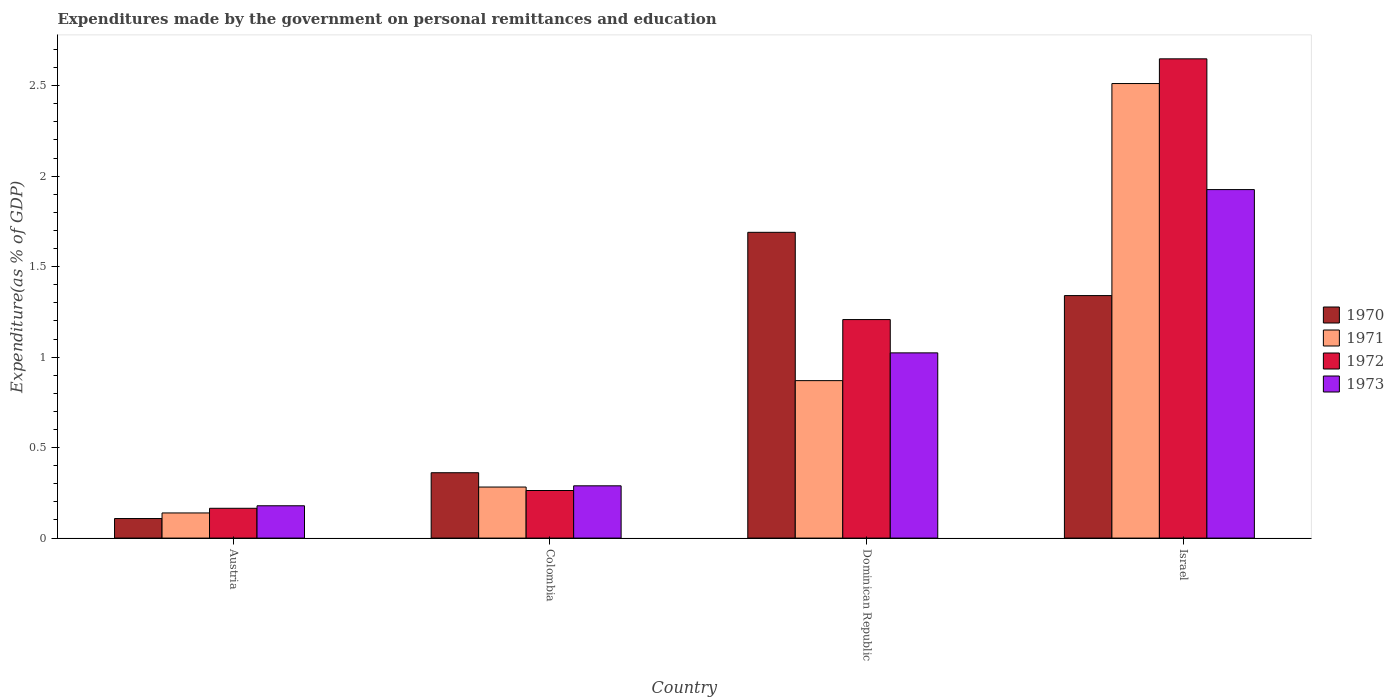How many different coloured bars are there?
Keep it short and to the point. 4. How many bars are there on the 4th tick from the left?
Make the answer very short. 4. How many bars are there on the 1st tick from the right?
Provide a short and direct response. 4. What is the label of the 3rd group of bars from the left?
Provide a succinct answer. Dominican Republic. What is the expenditures made by the government on personal remittances and education in 1973 in Austria?
Your response must be concise. 0.18. Across all countries, what is the maximum expenditures made by the government on personal remittances and education in 1973?
Your answer should be compact. 1.93. Across all countries, what is the minimum expenditures made by the government on personal remittances and education in 1972?
Provide a short and direct response. 0.16. In which country was the expenditures made by the government on personal remittances and education in 1971 minimum?
Provide a succinct answer. Austria. What is the total expenditures made by the government on personal remittances and education in 1970 in the graph?
Your answer should be very brief. 3.5. What is the difference between the expenditures made by the government on personal remittances and education in 1973 in Dominican Republic and that in Israel?
Your answer should be very brief. -0.9. What is the difference between the expenditures made by the government on personal remittances and education in 1971 in Colombia and the expenditures made by the government on personal remittances and education in 1972 in Dominican Republic?
Ensure brevity in your answer.  -0.93. What is the average expenditures made by the government on personal remittances and education in 1971 per country?
Make the answer very short. 0.95. What is the difference between the expenditures made by the government on personal remittances and education of/in 1972 and expenditures made by the government on personal remittances and education of/in 1971 in Colombia?
Keep it short and to the point. -0.02. What is the ratio of the expenditures made by the government on personal remittances and education in 1971 in Colombia to that in Dominican Republic?
Ensure brevity in your answer.  0.32. Is the expenditures made by the government on personal remittances and education in 1970 in Austria less than that in Dominican Republic?
Your answer should be compact. Yes. Is the difference between the expenditures made by the government on personal remittances and education in 1972 in Colombia and Dominican Republic greater than the difference between the expenditures made by the government on personal remittances and education in 1971 in Colombia and Dominican Republic?
Provide a short and direct response. No. What is the difference between the highest and the second highest expenditures made by the government on personal remittances and education in 1970?
Offer a terse response. -1.33. What is the difference between the highest and the lowest expenditures made by the government on personal remittances and education in 1971?
Ensure brevity in your answer.  2.37. Is it the case that in every country, the sum of the expenditures made by the government on personal remittances and education in 1971 and expenditures made by the government on personal remittances and education in 1973 is greater than the sum of expenditures made by the government on personal remittances and education in 1972 and expenditures made by the government on personal remittances and education in 1970?
Your answer should be compact. No. What does the 2nd bar from the left in Israel represents?
Keep it short and to the point. 1971. What does the 3rd bar from the right in Colombia represents?
Offer a very short reply. 1971. Is it the case that in every country, the sum of the expenditures made by the government on personal remittances and education in 1972 and expenditures made by the government on personal remittances and education in 1971 is greater than the expenditures made by the government on personal remittances and education in 1970?
Ensure brevity in your answer.  Yes. What is the difference between two consecutive major ticks on the Y-axis?
Your answer should be very brief. 0.5. Does the graph contain any zero values?
Give a very brief answer. No. Does the graph contain grids?
Provide a short and direct response. No. Where does the legend appear in the graph?
Provide a succinct answer. Center right. How are the legend labels stacked?
Your response must be concise. Vertical. What is the title of the graph?
Provide a short and direct response. Expenditures made by the government on personal remittances and education. What is the label or title of the X-axis?
Ensure brevity in your answer.  Country. What is the label or title of the Y-axis?
Give a very brief answer. Expenditure(as % of GDP). What is the Expenditure(as % of GDP) of 1970 in Austria?
Your response must be concise. 0.11. What is the Expenditure(as % of GDP) in 1971 in Austria?
Make the answer very short. 0.14. What is the Expenditure(as % of GDP) in 1972 in Austria?
Provide a short and direct response. 0.16. What is the Expenditure(as % of GDP) of 1973 in Austria?
Provide a short and direct response. 0.18. What is the Expenditure(as % of GDP) in 1970 in Colombia?
Offer a very short reply. 0.36. What is the Expenditure(as % of GDP) of 1971 in Colombia?
Give a very brief answer. 0.28. What is the Expenditure(as % of GDP) of 1972 in Colombia?
Your answer should be compact. 0.26. What is the Expenditure(as % of GDP) of 1973 in Colombia?
Your answer should be compact. 0.29. What is the Expenditure(as % of GDP) of 1970 in Dominican Republic?
Offer a terse response. 1.69. What is the Expenditure(as % of GDP) in 1971 in Dominican Republic?
Your response must be concise. 0.87. What is the Expenditure(as % of GDP) in 1972 in Dominican Republic?
Provide a succinct answer. 1.21. What is the Expenditure(as % of GDP) in 1973 in Dominican Republic?
Ensure brevity in your answer.  1.02. What is the Expenditure(as % of GDP) in 1970 in Israel?
Offer a very short reply. 1.34. What is the Expenditure(as % of GDP) of 1971 in Israel?
Give a very brief answer. 2.51. What is the Expenditure(as % of GDP) in 1972 in Israel?
Offer a very short reply. 2.65. What is the Expenditure(as % of GDP) of 1973 in Israel?
Your answer should be very brief. 1.93. Across all countries, what is the maximum Expenditure(as % of GDP) in 1970?
Provide a short and direct response. 1.69. Across all countries, what is the maximum Expenditure(as % of GDP) of 1971?
Keep it short and to the point. 2.51. Across all countries, what is the maximum Expenditure(as % of GDP) of 1972?
Make the answer very short. 2.65. Across all countries, what is the maximum Expenditure(as % of GDP) of 1973?
Keep it short and to the point. 1.93. Across all countries, what is the minimum Expenditure(as % of GDP) in 1970?
Your response must be concise. 0.11. Across all countries, what is the minimum Expenditure(as % of GDP) of 1971?
Your answer should be very brief. 0.14. Across all countries, what is the minimum Expenditure(as % of GDP) of 1972?
Offer a terse response. 0.16. Across all countries, what is the minimum Expenditure(as % of GDP) in 1973?
Offer a terse response. 0.18. What is the total Expenditure(as % of GDP) of 1970 in the graph?
Provide a short and direct response. 3.5. What is the total Expenditure(as % of GDP) in 1971 in the graph?
Offer a terse response. 3.8. What is the total Expenditure(as % of GDP) of 1972 in the graph?
Offer a terse response. 4.28. What is the total Expenditure(as % of GDP) of 1973 in the graph?
Provide a succinct answer. 3.42. What is the difference between the Expenditure(as % of GDP) of 1970 in Austria and that in Colombia?
Offer a terse response. -0.25. What is the difference between the Expenditure(as % of GDP) of 1971 in Austria and that in Colombia?
Offer a very short reply. -0.14. What is the difference between the Expenditure(as % of GDP) of 1972 in Austria and that in Colombia?
Your answer should be very brief. -0.1. What is the difference between the Expenditure(as % of GDP) in 1973 in Austria and that in Colombia?
Your answer should be compact. -0.11. What is the difference between the Expenditure(as % of GDP) in 1970 in Austria and that in Dominican Republic?
Provide a short and direct response. -1.58. What is the difference between the Expenditure(as % of GDP) in 1971 in Austria and that in Dominican Republic?
Keep it short and to the point. -0.73. What is the difference between the Expenditure(as % of GDP) of 1972 in Austria and that in Dominican Republic?
Your answer should be very brief. -1.04. What is the difference between the Expenditure(as % of GDP) in 1973 in Austria and that in Dominican Republic?
Give a very brief answer. -0.84. What is the difference between the Expenditure(as % of GDP) in 1970 in Austria and that in Israel?
Ensure brevity in your answer.  -1.23. What is the difference between the Expenditure(as % of GDP) in 1971 in Austria and that in Israel?
Ensure brevity in your answer.  -2.37. What is the difference between the Expenditure(as % of GDP) of 1972 in Austria and that in Israel?
Offer a terse response. -2.48. What is the difference between the Expenditure(as % of GDP) of 1973 in Austria and that in Israel?
Offer a very short reply. -1.75. What is the difference between the Expenditure(as % of GDP) in 1970 in Colombia and that in Dominican Republic?
Offer a very short reply. -1.33. What is the difference between the Expenditure(as % of GDP) in 1971 in Colombia and that in Dominican Republic?
Offer a terse response. -0.59. What is the difference between the Expenditure(as % of GDP) in 1972 in Colombia and that in Dominican Republic?
Your answer should be compact. -0.94. What is the difference between the Expenditure(as % of GDP) in 1973 in Colombia and that in Dominican Republic?
Give a very brief answer. -0.73. What is the difference between the Expenditure(as % of GDP) in 1970 in Colombia and that in Israel?
Provide a succinct answer. -0.98. What is the difference between the Expenditure(as % of GDP) in 1971 in Colombia and that in Israel?
Provide a succinct answer. -2.23. What is the difference between the Expenditure(as % of GDP) of 1972 in Colombia and that in Israel?
Make the answer very short. -2.39. What is the difference between the Expenditure(as % of GDP) of 1973 in Colombia and that in Israel?
Provide a short and direct response. -1.64. What is the difference between the Expenditure(as % of GDP) in 1970 in Dominican Republic and that in Israel?
Your answer should be very brief. 0.35. What is the difference between the Expenditure(as % of GDP) in 1971 in Dominican Republic and that in Israel?
Make the answer very short. -1.64. What is the difference between the Expenditure(as % of GDP) in 1972 in Dominican Republic and that in Israel?
Provide a succinct answer. -1.44. What is the difference between the Expenditure(as % of GDP) in 1973 in Dominican Republic and that in Israel?
Ensure brevity in your answer.  -0.9. What is the difference between the Expenditure(as % of GDP) of 1970 in Austria and the Expenditure(as % of GDP) of 1971 in Colombia?
Keep it short and to the point. -0.17. What is the difference between the Expenditure(as % of GDP) of 1970 in Austria and the Expenditure(as % of GDP) of 1972 in Colombia?
Your response must be concise. -0.15. What is the difference between the Expenditure(as % of GDP) of 1970 in Austria and the Expenditure(as % of GDP) of 1973 in Colombia?
Provide a succinct answer. -0.18. What is the difference between the Expenditure(as % of GDP) in 1971 in Austria and the Expenditure(as % of GDP) in 1972 in Colombia?
Your response must be concise. -0.12. What is the difference between the Expenditure(as % of GDP) of 1971 in Austria and the Expenditure(as % of GDP) of 1973 in Colombia?
Ensure brevity in your answer.  -0.15. What is the difference between the Expenditure(as % of GDP) of 1972 in Austria and the Expenditure(as % of GDP) of 1973 in Colombia?
Your response must be concise. -0.12. What is the difference between the Expenditure(as % of GDP) of 1970 in Austria and the Expenditure(as % of GDP) of 1971 in Dominican Republic?
Offer a terse response. -0.76. What is the difference between the Expenditure(as % of GDP) of 1970 in Austria and the Expenditure(as % of GDP) of 1972 in Dominican Republic?
Your response must be concise. -1.1. What is the difference between the Expenditure(as % of GDP) in 1970 in Austria and the Expenditure(as % of GDP) in 1973 in Dominican Republic?
Ensure brevity in your answer.  -0.92. What is the difference between the Expenditure(as % of GDP) of 1971 in Austria and the Expenditure(as % of GDP) of 1972 in Dominican Republic?
Provide a short and direct response. -1.07. What is the difference between the Expenditure(as % of GDP) of 1971 in Austria and the Expenditure(as % of GDP) of 1973 in Dominican Republic?
Your answer should be compact. -0.88. What is the difference between the Expenditure(as % of GDP) in 1972 in Austria and the Expenditure(as % of GDP) in 1973 in Dominican Republic?
Your answer should be compact. -0.86. What is the difference between the Expenditure(as % of GDP) of 1970 in Austria and the Expenditure(as % of GDP) of 1971 in Israel?
Ensure brevity in your answer.  -2.4. What is the difference between the Expenditure(as % of GDP) in 1970 in Austria and the Expenditure(as % of GDP) in 1972 in Israel?
Give a very brief answer. -2.54. What is the difference between the Expenditure(as % of GDP) in 1970 in Austria and the Expenditure(as % of GDP) in 1973 in Israel?
Ensure brevity in your answer.  -1.82. What is the difference between the Expenditure(as % of GDP) of 1971 in Austria and the Expenditure(as % of GDP) of 1972 in Israel?
Your answer should be very brief. -2.51. What is the difference between the Expenditure(as % of GDP) in 1971 in Austria and the Expenditure(as % of GDP) in 1973 in Israel?
Keep it short and to the point. -1.79. What is the difference between the Expenditure(as % of GDP) of 1972 in Austria and the Expenditure(as % of GDP) of 1973 in Israel?
Keep it short and to the point. -1.76. What is the difference between the Expenditure(as % of GDP) in 1970 in Colombia and the Expenditure(as % of GDP) in 1971 in Dominican Republic?
Make the answer very short. -0.51. What is the difference between the Expenditure(as % of GDP) of 1970 in Colombia and the Expenditure(as % of GDP) of 1972 in Dominican Republic?
Give a very brief answer. -0.85. What is the difference between the Expenditure(as % of GDP) of 1970 in Colombia and the Expenditure(as % of GDP) of 1973 in Dominican Republic?
Ensure brevity in your answer.  -0.66. What is the difference between the Expenditure(as % of GDP) of 1971 in Colombia and the Expenditure(as % of GDP) of 1972 in Dominican Republic?
Provide a succinct answer. -0.93. What is the difference between the Expenditure(as % of GDP) of 1971 in Colombia and the Expenditure(as % of GDP) of 1973 in Dominican Republic?
Give a very brief answer. -0.74. What is the difference between the Expenditure(as % of GDP) in 1972 in Colombia and the Expenditure(as % of GDP) in 1973 in Dominican Republic?
Your response must be concise. -0.76. What is the difference between the Expenditure(as % of GDP) of 1970 in Colombia and the Expenditure(as % of GDP) of 1971 in Israel?
Your response must be concise. -2.15. What is the difference between the Expenditure(as % of GDP) in 1970 in Colombia and the Expenditure(as % of GDP) in 1972 in Israel?
Ensure brevity in your answer.  -2.29. What is the difference between the Expenditure(as % of GDP) of 1970 in Colombia and the Expenditure(as % of GDP) of 1973 in Israel?
Make the answer very short. -1.56. What is the difference between the Expenditure(as % of GDP) of 1971 in Colombia and the Expenditure(as % of GDP) of 1972 in Israel?
Your answer should be very brief. -2.37. What is the difference between the Expenditure(as % of GDP) in 1971 in Colombia and the Expenditure(as % of GDP) in 1973 in Israel?
Your response must be concise. -1.64. What is the difference between the Expenditure(as % of GDP) of 1972 in Colombia and the Expenditure(as % of GDP) of 1973 in Israel?
Make the answer very short. -1.66. What is the difference between the Expenditure(as % of GDP) of 1970 in Dominican Republic and the Expenditure(as % of GDP) of 1971 in Israel?
Keep it short and to the point. -0.82. What is the difference between the Expenditure(as % of GDP) of 1970 in Dominican Republic and the Expenditure(as % of GDP) of 1972 in Israel?
Ensure brevity in your answer.  -0.96. What is the difference between the Expenditure(as % of GDP) of 1970 in Dominican Republic and the Expenditure(as % of GDP) of 1973 in Israel?
Offer a very short reply. -0.24. What is the difference between the Expenditure(as % of GDP) in 1971 in Dominican Republic and the Expenditure(as % of GDP) in 1972 in Israel?
Make the answer very short. -1.78. What is the difference between the Expenditure(as % of GDP) of 1971 in Dominican Republic and the Expenditure(as % of GDP) of 1973 in Israel?
Offer a very short reply. -1.06. What is the difference between the Expenditure(as % of GDP) of 1972 in Dominican Republic and the Expenditure(as % of GDP) of 1973 in Israel?
Offer a very short reply. -0.72. What is the average Expenditure(as % of GDP) of 1970 per country?
Keep it short and to the point. 0.87. What is the average Expenditure(as % of GDP) in 1971 per country?
Ensure brevity in your answer.  0.95. What is the average Expenditure(as % of GDP) of 1972 per country?
Provide a succinct answer. 1.07. What is the average Expenditure(as % of GDP) of 1973 per country?
Your answer should be compact. 0.85. What is the difference between the Expenditure(as % of GDP) in 1970 and Expenditure(as % of GDP) in 1971 in Austria?
Your answer should be very brief. -0.03. What is the difference between the Expenditure(as % of GDP) of 1970 and Expenditure(as % of GDP) of 1972 in Austria?
Provide a short and direct response. -0.06. What is the difference between the Expenditure(as % of GDP) in 1970 and Expenditure(as % of GDP) in 1973 in Austria?
Provide a short and direct response. -0.07. What is the difference between the Expenditure(as % of GDP) of 1971 and Expenditure(as % of GDP) of 1972 in Austria?
Your response must be concise. -0.03. What is the difference between the Expenditure(as % of GDP) of 1971 and Expenditure(as % of GDP) of 1973 in Austria?
Give a very brief answer. -0.04. What is the difference between the Expenditure(as % of GDP) in 1972 and Expenditure(as % of GDP) in 1973 in Austria?
Ensure brevity in your answer.  -0.01. What is the difference between the Expenditure(as % of GDP) of 1970 and Expenditure(as % of GDP) of 1971 in Colombia?
Your answer should be very brief. 0.08. What is the difference between the Expenditure(as % of GDP) of 1970 and Expenditure(as % of GDP) of 1972 in Colombia?
Keep it short and to the point. 0.1. What is the difference between the Expenditure(as % of GDP) of 1970 and Expenditure(as % of GDP) of 1973 in Colombia?
Give a very brief answer. 0.07. What is the difference between the Expenditure(as % of GDP) of 1971 and Expenditure(as % of GDP) of 1972 in Colombia?
Make the answer very short. 0.02. What is the difference between the Expenditure(as % of GDP) in 1971 and Expenditure(as % of GDP) in 1973 in Colombia?
Offer a terse response. -0.01. What is the difference between the Expenditure(as % of GDP) in 1972 and Expenditure(as % of GDP) in 1973 in Colombia?
Your response must be concise. -0.03. What is the difference between the Expenditure(as % of GDP) in 1970 and Expenditure(as % of GDP) in 1971 in Dominican Republic?
Keep it short and to the point. 0.82. What is the difference between the Expenditure(as % of GDP) of 1970 and Expenditure(as % of GDP) of 1972 in Dominican Republic?
Offer a very short reply. 0.48. What is the difference between the Expenditure(as % of GDP) in 1970 and Expenditure(as % of GDP) in 1973 in Dominican Republic?
Offer a terse response. 0.67. What is the difference between the Expenditure(as % of GDP) in 1971 and Expenditure(as % of GDP) in 1972 in Dominican Republic?
Offer a very short reply. -0.34. What is the difference between the Expenditure(as % of GDP) in 1971 and Expenditure(as % of GDP) in 1973 in Dominican Republic?
Provide a short and direct response. -0.15. What is the difference between the Expenditure(as % of GDP) in 1972 and Expenditure(as % of GDP) in 1973 in Dominican Republic?
Your answer should be very brief. 0.18. What is the difference between the Expenditure(as % of GDP) in 1970 and Expenditure(as % of GDP) in 1971 in Israel?
Keep it short and to the point. -1.17. What is the difference between the Expenditure(as % of GDP) in 1970 and Expenditure(as % of GDP) in 1972 in Israel?
Your response must be concise. -1.31. What is the difference between the Expenditure(as % of GDP) of 1970 and Expenditure(as % of GDP) of 1973 in Israel?
Your response must be concise. -0.59. What is the difference between the Expenditure(as % of GDP) in 1971 and Expenditure(as % of GDP) in 1972 in Israel?
Provide a short and direct response. -0.14. What is the difference between the Expenditure(as % of GDP) in 1971 and Expenditure(as % of GDP) in 1973 in Israel?
Your answer should be very brief. 0.59. What is the difference between the Expenditure(as % of GDP) of 1972 and Expenditure(as % of GDP) of 1973 in Israel?
Keep it short and to the point. 0.72. What is the ratio of the Expenditure(as % of GDP) in 1970 in Austria to that in Colombia?
Keep it short and to the point. 0.3. What is the ratio of the Expenditure(as % of GDP) in 1971 in Austria to that in Colombia?
Your answer should be compact. 0.49. What is the ratio of the Expenditure(as % of GDP) in 1972 in Austria to that in Colombia?
Provide a short and direct response. 0.63. What is the ratio of the Expenditure(as % of GDP) of 1973 in Austria to that in Colombia?
Make the answer very short. 0.62. What is the ratio of the Expenditure(as % of GDP) in 1970 in Austria to that in Dominican Republic?
Give a very brief answer. 0.06. What is the ratio of the Expenditure(as % of GDP) in 1971 in Austria to that in Dominican Republic?
Your answer should be compact. 0.16. What is the ratio of the Expenditure(as % of GDP) in 1972 in Austria to that in Dominican Republic?
Your response must be concise. 0.14. What is the ratio of the Expenditure(as % of GDP) of 1973 in Austria to that in Dominican Republic?
Your answer should be compact. 0.17. What is the ratio of the Expenditure(as % of GDP) in 1970 in Austria to that in Israel?
Keep it short and to the point. 0.08. What is the ratio of the Expenditure(as % of GDP) in 1971 in Austria to that in Israel?
Give a very brief answer. 0.06. What is the ratio of the Expenditure(as % of GDP) of 1972 in Austria to that in Israel?
Keep it short and to the point. 0.06. What is the ratio of the Expenditure(as % of GDP) in 1973 in Austria to that in Israel?
Offer a terse response. 0.09. What is the ratio of the Expenditure(as % of GDP) of 1970 in Colombia to that in Dominican Republic?
Offer a very short reply. 0.21. What is the ratio of the Expenditure(as % of GDP) of 1971 in Colombia to that in Dominican Republic?
Your answer should be very brief. 0.32. What is the ratio of the Expenditure(as % of GDP) in 1972 in Colombia to that in Dominican Republic?
Give a very brief answer. 0.22. What is the ratio of the Expenditure(as % of GDP) in 1973 in Colombia to that in Dominican Republic?
Make the answer very short. 0.28. What is the ratio of the Expenditure(as % of GDP) of 1970 in Colombia to that in Israel?
Provide a succinct answer. 0.27. What is the ratio of the Expenditure(as % of GDP) in 1971 in Colombia to that in Israel?
Provide a succinct answer. 0.11. What is the ratio of the Expenditure(as % of GDP) in 1972 in Colombia to that in Israel?
Give a very brief answer. 0.1. What is the ratio of the Expenditure(as % of GDP) of 1970 in Dominican Republic to that in Israel?
Your answer should be very brief. 1.26. What is the ratio of the Expenditure(as % of GDP) of 1971 in Dominican Republic to that in Israel?
Provide a short and direct response. 0.35. What is the ratio of the Expenditure(as % of GDP) of 1972 in Dominican Republic to that in Israel?
Ensure brevity in your answer.  0.46. What is the ratio of the Expenditure(as % of GDP) in 1973 in Dominican Republic to that in Israel?
Your answer should be very brief. 0.53. What is the difference between the highest and the second highest Expenditure(as % of GDP) of 1970?
Make the answer very short. 0.35. What is the difference between the highest and the second highest Expenditure(as % of GDP) of 1971?
Provide a short and direct response. 1.64. What is the difference between the highest and the second highest Expenditure(as % of GDP) in 1972?
Offer a terse response. 1.44. What is the difference between the highest and the second highest Expenditure(as % of GDP) of 1973?
Provide a succinct answer. 0.9. What is the difference between the highest and the lowest Expenditure(as % of GDP) of 1970?
Give a very brief answer. 1.58. What is the difference between the highest and the lowest Expenditure(as % of GDP) of 1971?
Your response must be concise. 2.37. What is the difference between the highest and the lowest Expenditure(as % of GDP) of 1972?
Your response must be concise. 2.48. What is the difference between the highest and the lowest Expenditure(as % of GDP) of 1973?
Offer a terse response. 1.75. 